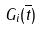Convert formula to latex. <formula><loc_0><loc_0><loc_500><loc_500>G _ { i } ( \overline { t } )</formula> 